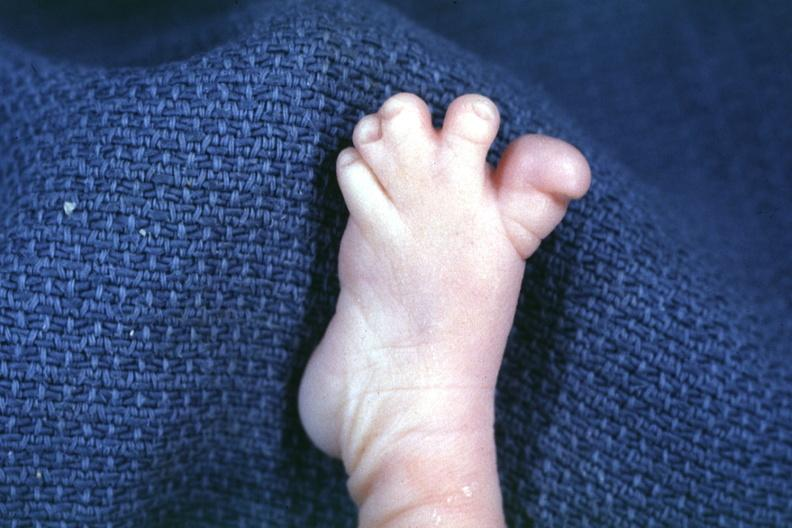s tuberculosis present?
Answer the question using a single word or phrase. No 